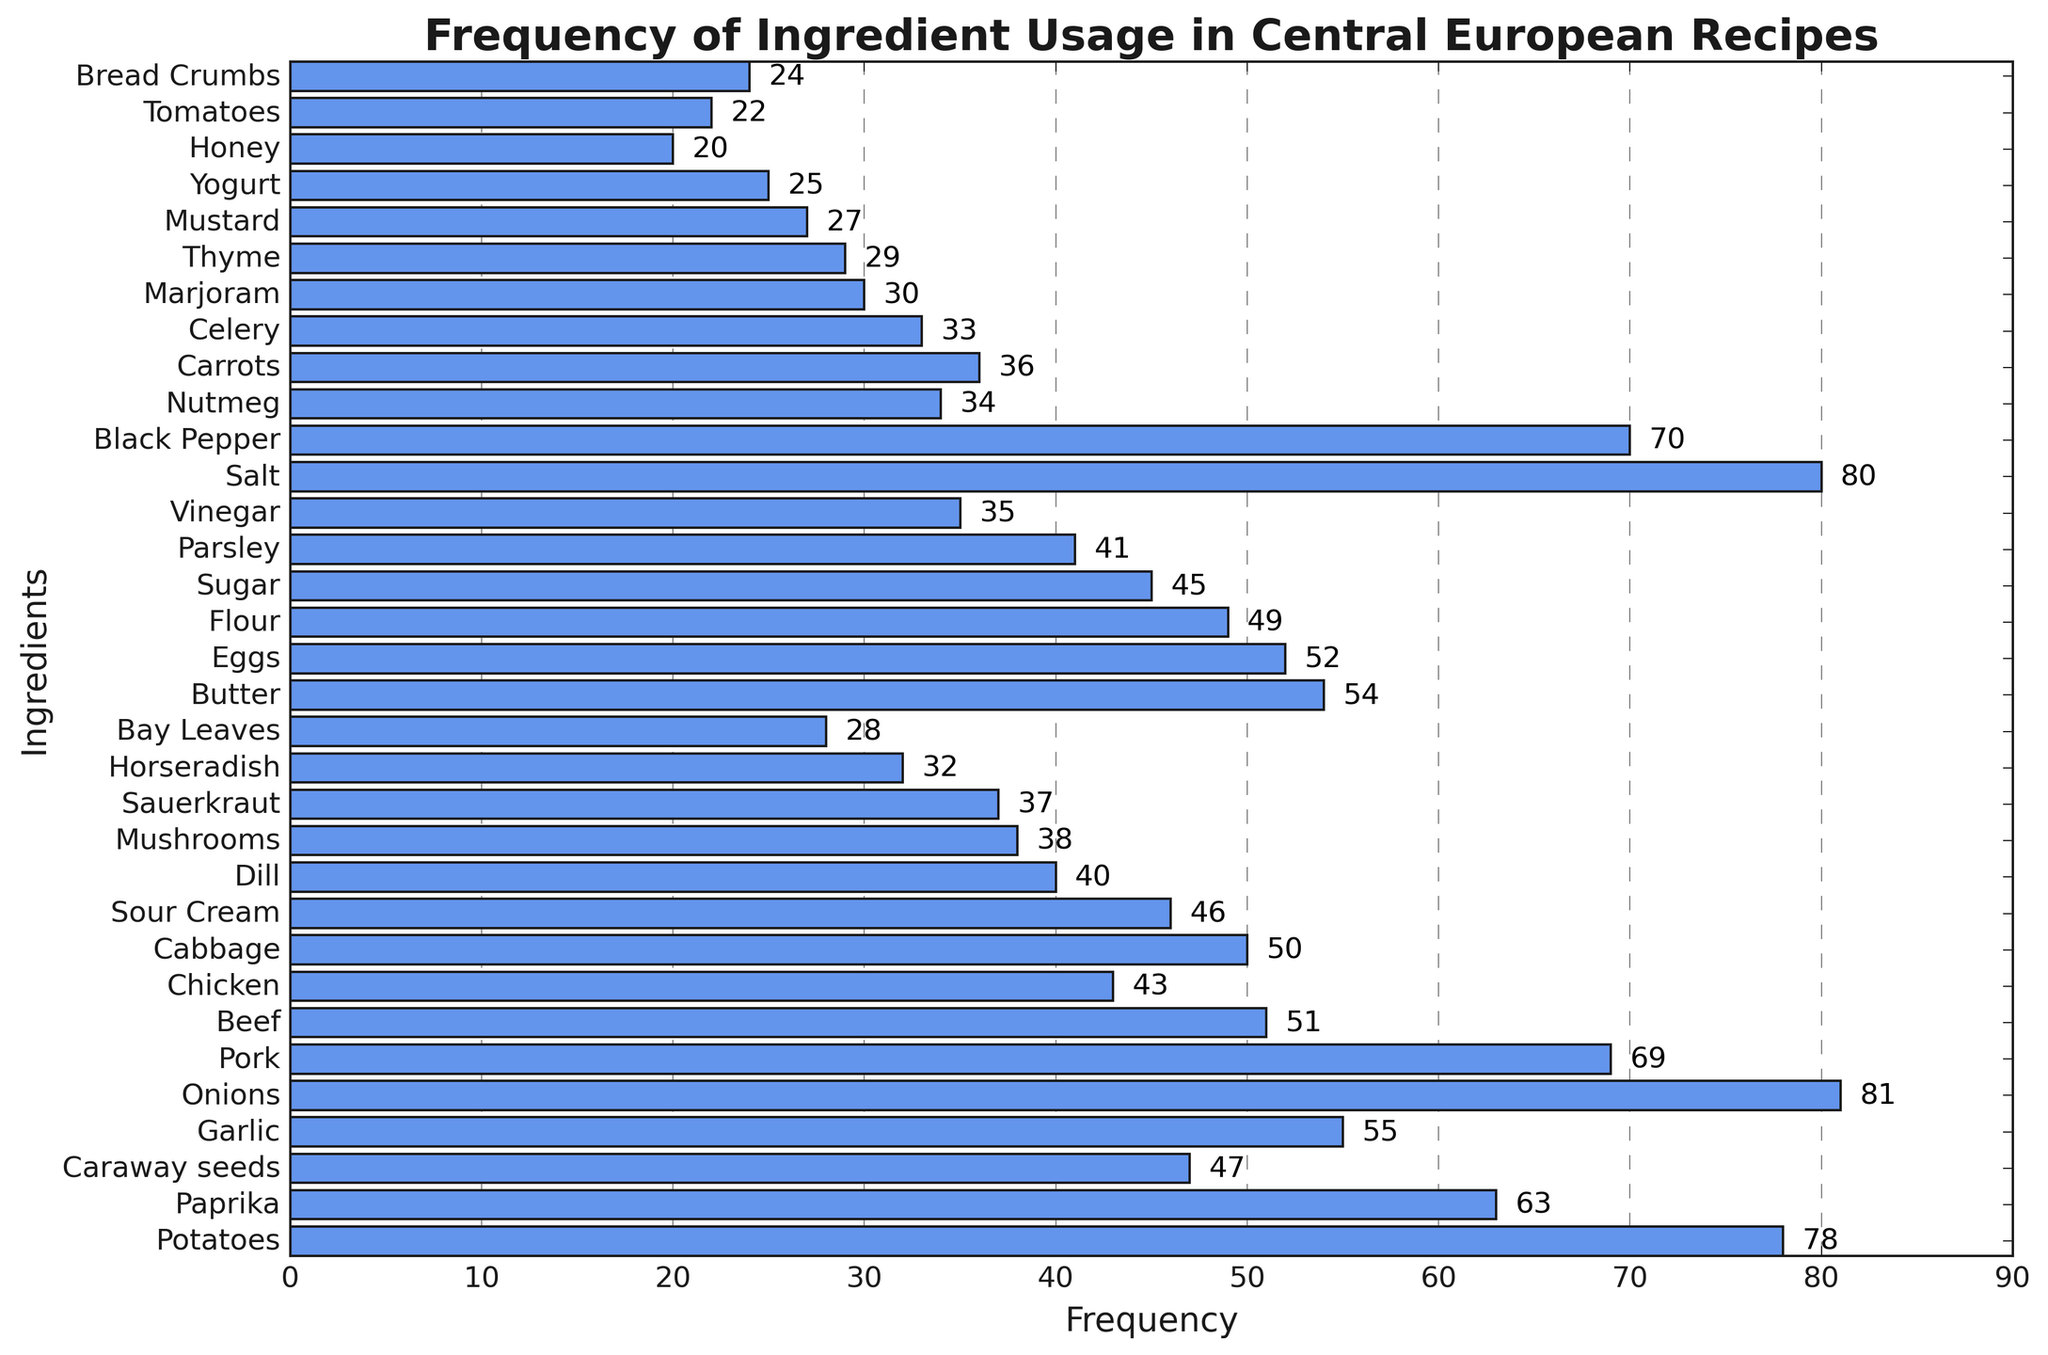Which ingredient is used the most in Central European recipes? By examining the lengths of the bars representing each ingredient, the ingredient with the longest bar is "Onions" with a frequency of 81.
Answer: Onions Which two ingredients have nearly the same usage frequency? By comparing the bar lengths visually, "Cabbage" and "Beef" have frequencies close to each other with Cabbage at 50 and Beef at 51.
Answer: Cabbage and Beef What is the combined frequency of usage for Paprika, Caraway seeds, and Garlic? Adding the individual frequencies from the figure: Paprika (63) + Caraway seeds (47) + Garlic (55) = 165
Answer: 165 Which ingredient is used more frequently, Pork or Black Pepper, and by how much? By comparing the bar lengths for Pork (69) and Black Pepper (70), Black Pepper is used more frequently by 1.
Answer: Black Pepper, 1 How many ingredients have a frequency above 60? Counting the bars with a frequency greater than 60: Potatoes, Paprika, Onions, Pork, and Black Pepper makes 5 ingredients.
Answer: 5 What is the median frequency value of all the ingredients? After sorting the frequencies, the middle value for 35 values would be the 18th value. Sorted frequencies: [20, 22, 24, 25, 27, ..., 78, 80, 81]. The 18th value is 46.
Answer: 46 Which ingredient has the smallest usage frequency, and what is its value? By identifying the shortest bar in the histogram, the smallest frequency is for "Honey" with a value of 20.
Answer: Honey, 20 What is the difference in usage frequency between the least and the most used ingredients? Subtract the smallest frequency (Honey, 20) from the largest frequency (Onions, 81): 81 - 20 = 61
Answer: 61 Is sugar used in more recipes than vinegar? By comparing the bar lengths, Sugar has a frequency of 45, and Vinegar has a frequency of 35. So, yes, Sugar is used in more recipes.
Answer: Yes What's the average frequency of usage for Dill, Mushrooms, and Horseradish? Adding the frequencies and dividing by 3: (Dill (40) + Mushrooms (38) + Horseradish (32)) / 3 = 36.67
Answer: 36.67 